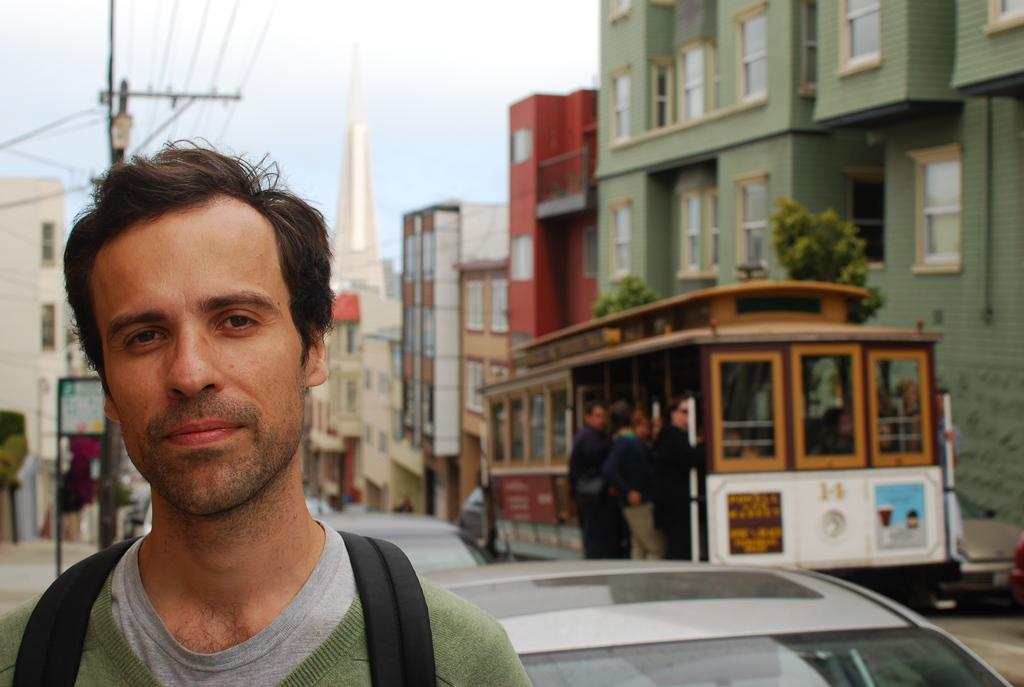Who is the main subject in the image? There is a person in the image. What can be observed about the background of the image? The background of the image is blurred. What type of structures are visible in the background? There are buildings in the background of the image. Can you describe any other objects in the background? There is a pole, a board, and vehicles in the background of the image. What else can be seen in the background? There are people and trees in the background of the image. What part of the natural environment is visible in the image? The sky is visible in the background of the image. Can you describe the setting where the person is located? The person is located near trees beside a vehicle in the image. What type of meal is the person eating in the image? There is no meal present in the image, and the person's actions are not described. 